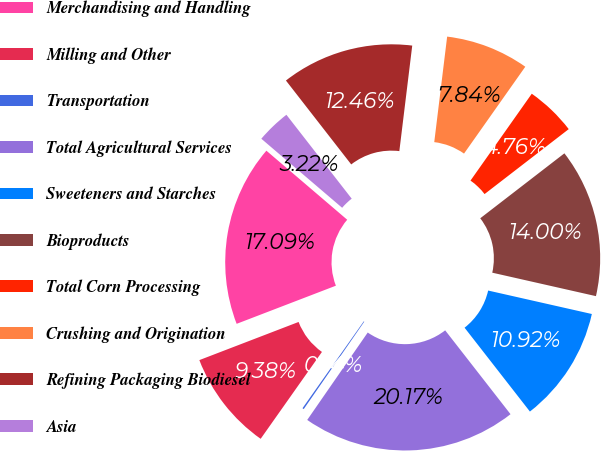Convert chart to OTSL. <chart><loc_0><loc_0><loc_500><loc_500><pie_chart><fcel>Merchandising and Handling<fcel>Milling and Other<fcel>Transportation<fcel>Total Agricultural Services<fcel>Sweeteners and Starches<fcel>Bioproducts<fcel>Total Corn Processing<fcel>Crushing and Origination<fcel>Refining Packaging Biodiesel<fcel>Asia<nl><fcel>17.09%<fcel>9.38%<fcel>0.14%<fcel>20.17%<fcel>10.92%<fcel>14.0%<fcel>4.76%<fcel>7.84%<fcel>12.46%<fcel>3.22%<nl></chart> 